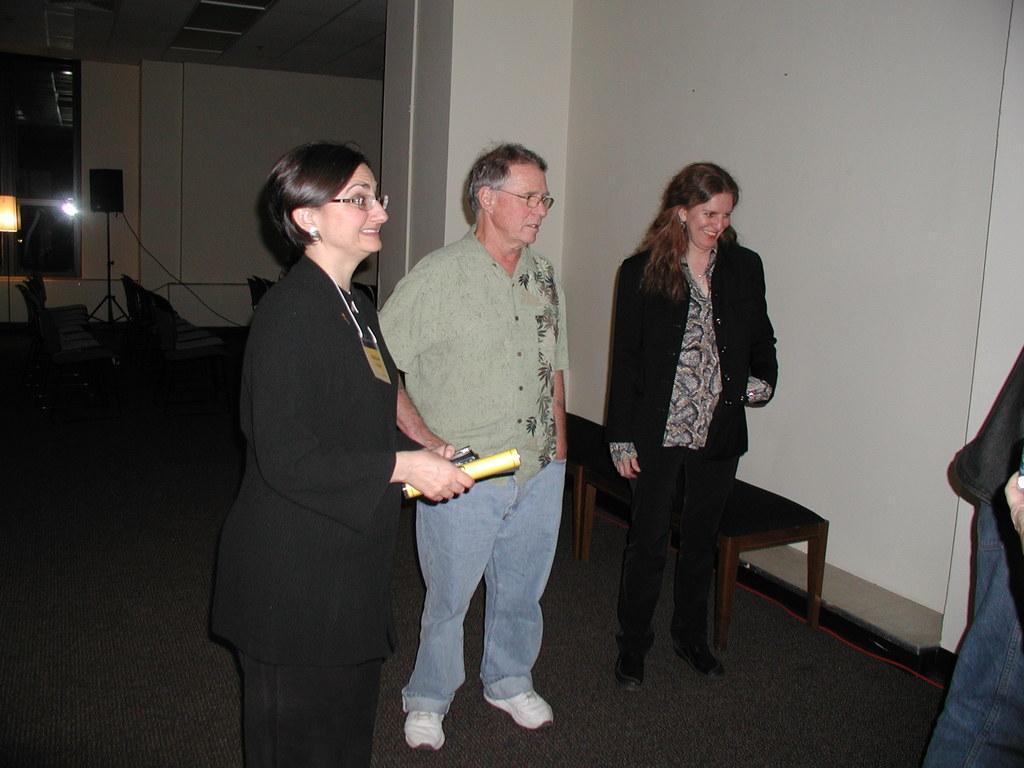Can you describe this image briefly? In this picture I can see few people are standing, among them one woman is holding some papers, side we can see some chairs, behind we can see some chairs, speaker boxes in a room. 